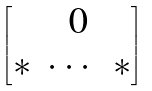<formula> <loc_0><loc_0><loc_500><loc_500>\begin{bmatrix} & \text { 0} \\ * & \cdots & * \end{bmatrix}</formula> 